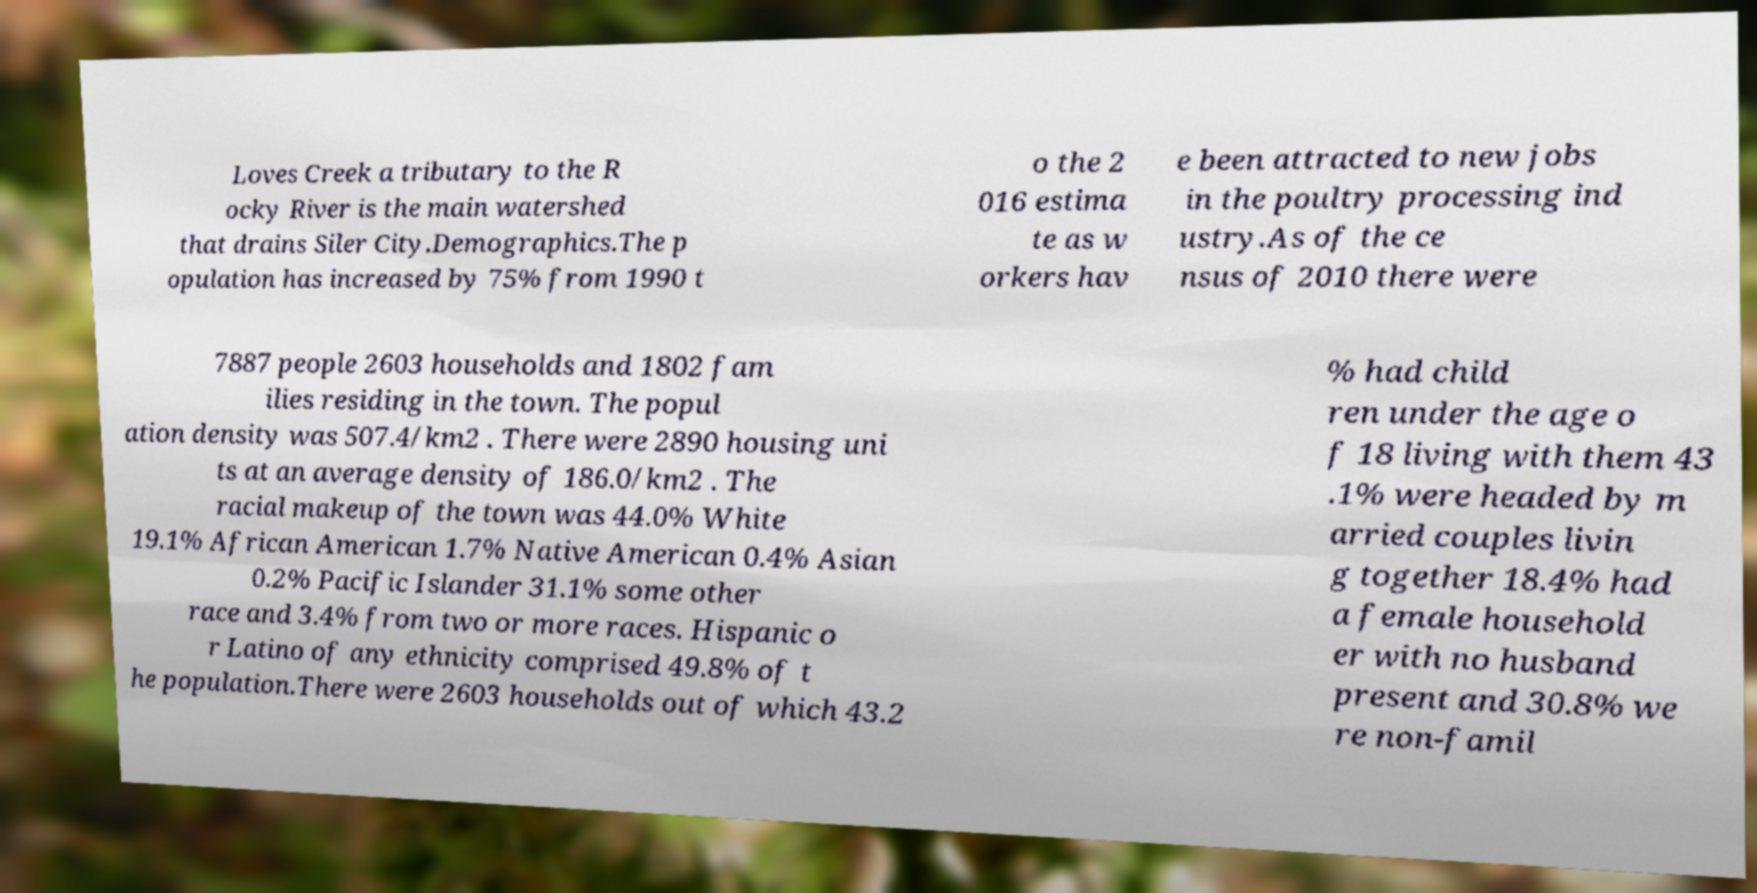Could you extract and type out the text from this image? Loves Creek a tributary to the R ocky River is the main watershed that drains Siler City.Demographics.The p opulation has increased by 75% from 1990 t o the 2 016 estima te as w orkers hav e been attracted to new jobs in the poultry processing ind ustry.As of the ce nsus of 2010 there were 7887 people 2603 households and 1802 fam ilies residing in the town. The popul ation density was 507.4/km2 . There were 2890 housing uni ts at an average density of 186.0/km2 . The racial makeup of the town was 44.0% White 19.1% African American 1.7% Native American 0.4% Asian 0.2% Pacific Islander 31.1% some other race and 3.4% from two or more races. Hispanic o r Latino of any ethnicity comprised 49.8% of t he population.There were 2603 households out of which 43.2 % had child ren under the age o f 18 living with them 43 .1% were headed by m arried couples livin g together 18.4% had a female household er with no husband present and 30.8% we re non-famil 